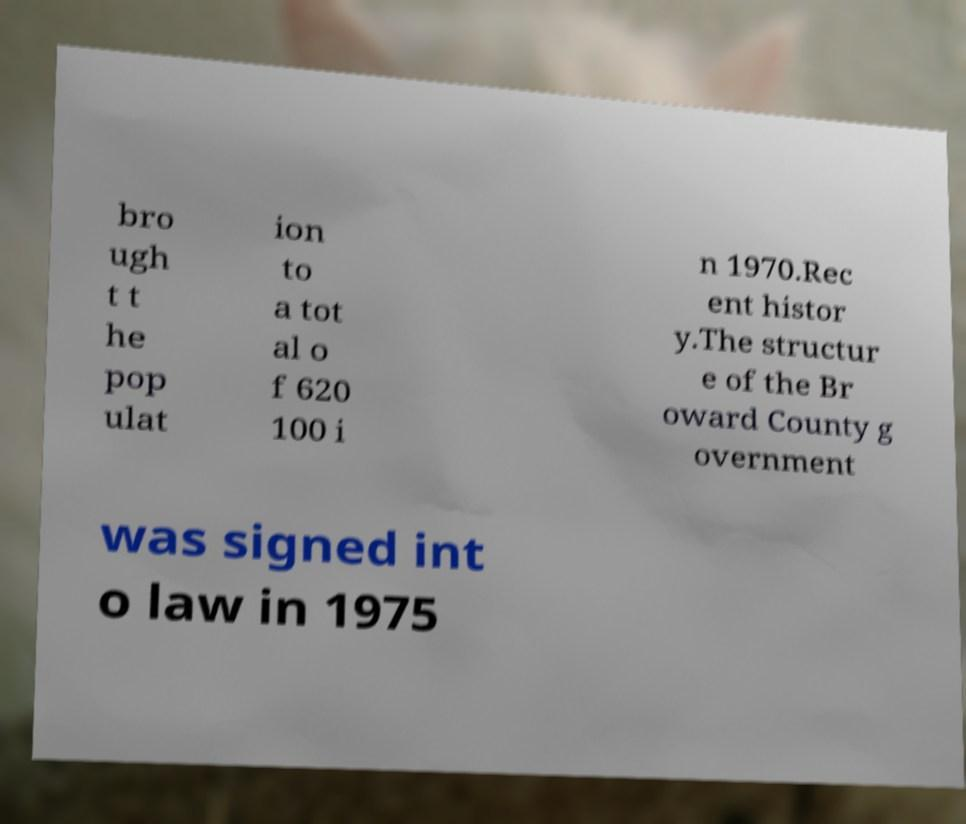Please identify and transcribe the text found in this image. bro ugh t t he pop ulat ion to a tot al o f 620 100 i n 1970.Rec ent histor y.The structur e of the Br oward County g overnment was signed int o law in 1975 